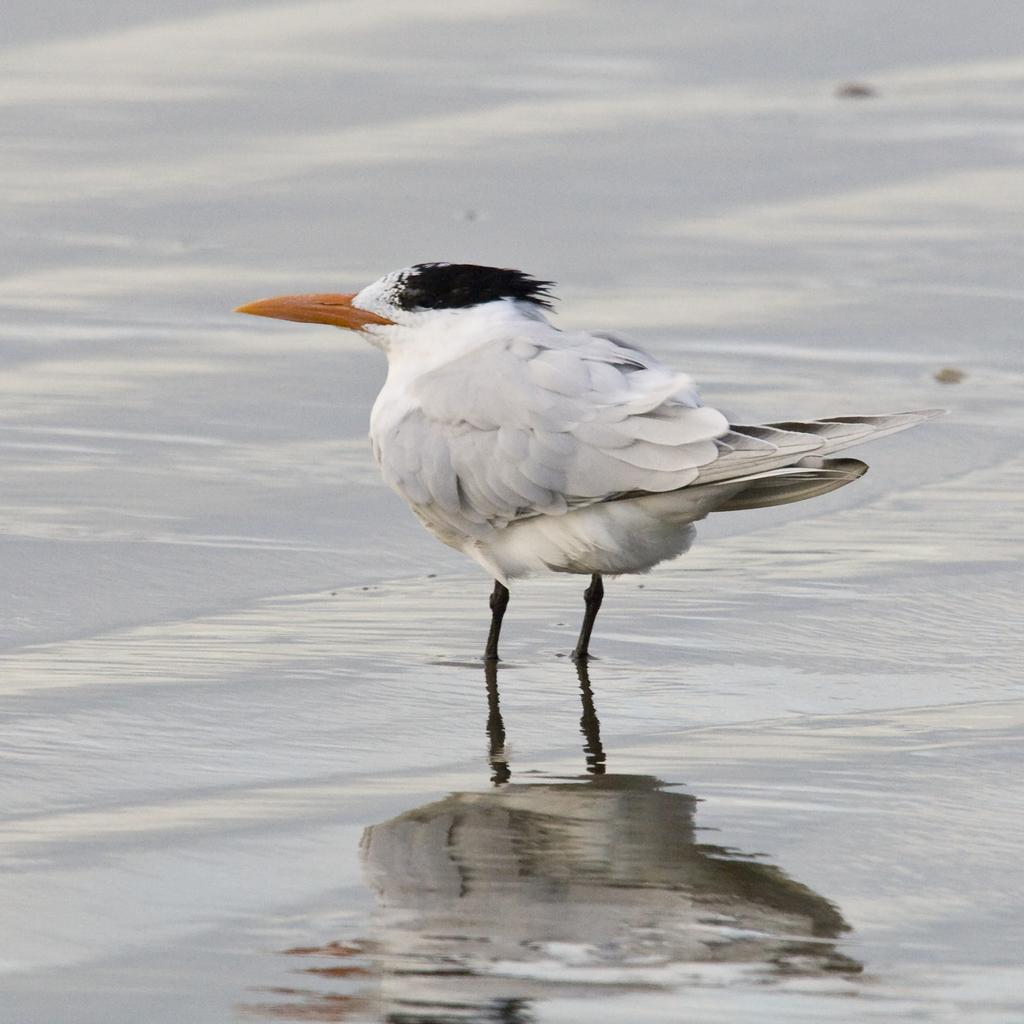What is the main subject in the center of the image? There is a bird in the center of the image. What can be seen at the bottom of the image? There is water at the bottom of the image. Where is the doll located in the image? There is no doll present in the image. What type of cheese can be seen growing in the garden in the image? There is no garden or cheese present in the image. 